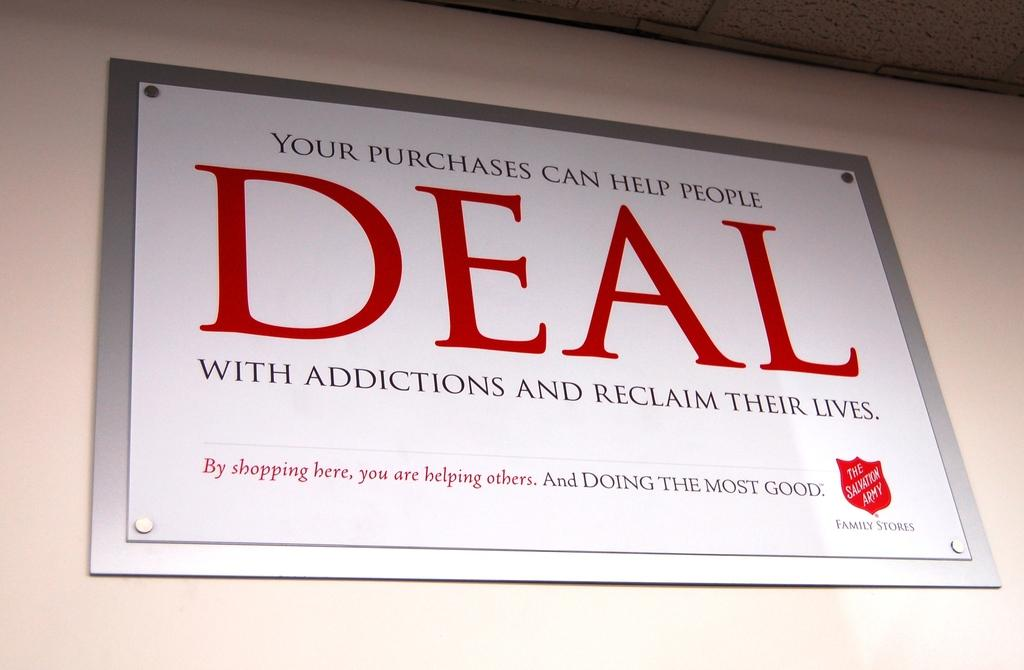<image>
Write a terse but informative summary of the picture. A sign from the Salvation Army on the wall encourages to help people deal with addictions and reclaim their lives. 